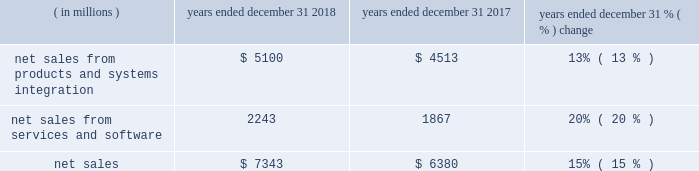Results of operations 20142018 compared to 2017 net sales .
The products and systems integration segment 2019s net sales represented 69% ( 69 % ) of our consolidated net sales in 2018 , compared to 71% ( 71 % ) in 2017 .
The services and software segment 2019s net sales represented 31% ( 31 % ) of our consolidated net sales in 2018 , compared to 29% ( 29 % ) in 2017 .
Net sales were up $ 963 million , or 15% ( 15 % ) , compared to 2017 .
The increase in net sales was driven by the americas and emea with a 13% ( 13 % ) increase in the products and systems integration segment and a 20% ( 20 % ) increase in the services and software segment .
This growth includes : 2022 $ 507 million of incremental revenue from the acquisitions of avigilon and plant in 2018 and kodiak networks and interexport which were acquired during 2017 ; 2022 $ 83 million from the adoption of accounting standards codification ( "asc" ) 606 ( see note 1 of our consolidated financial statements ) ; and 2022 $ 32 million from favorable currency rates .
Regional results include : 2022 the americas grew 17% ( 17 % ) across all products within both the products and systems integration and the services and software segments , inclusive of incremental revenue from acquisitions ; 2022 emea grew 18% ( 18 % ) on broad-based growth within all offerings within our products and systems integration and services and software segments , inclusive of incremental revenue from acquisitions ; and 2022 ap was relatively flat with growth in the services and software segment offset by lower products and systems integration revenue .
Products and systems integration the 13% ( 13 % ) growth in the products and systems integration segment was driven by the following : 2022 $ 318 million of incremental revenue from the acquisitions of avigilon in 2018 and interexport during 2017 ; 2022 $ 78 million from the adoption of asc 606 ; 2022 devices revenues were up significantly due to the acquisition of avigilon along with strong demand in the americas and emea ; and 2022 systems and systems integration revenues increased 10% ( 10 % ) in 2018 , as compared to 2017 driven by incremental revenue from avigilon , as well as system deployments in emea and ap .
Services and software the 20% ( 20 % ) growth in the services and software segment was driven by the following : 2022 $ 189 million of incremental revenue primarily from the acquisitions of plant and avigilon in 2018 and kodiak networks and interexport during 2017 ; 2022 $ 5 million from the adoption of asc 606 ; 2022 services were up $ 174 million , or 9% ( 9 % ) , driven by growth in both maintenance and managed service revenues , and incremental revenue from the acquisitions of interexport and plant ; and 2022 software was up $ 202 million , or 89% ( 89 % ) , driven primarily by incremental revenue from the acquisitions of plant , avigilon , and kodiak networks , and growth in our command center software suite. .
Without contributing favorable currency rates , what might the percentage increase of net sales be from 2017 to 2018? 
Rationale: 14.59%
Computations: ((7343 - 32) - 6380)
Answer: 931.0. 